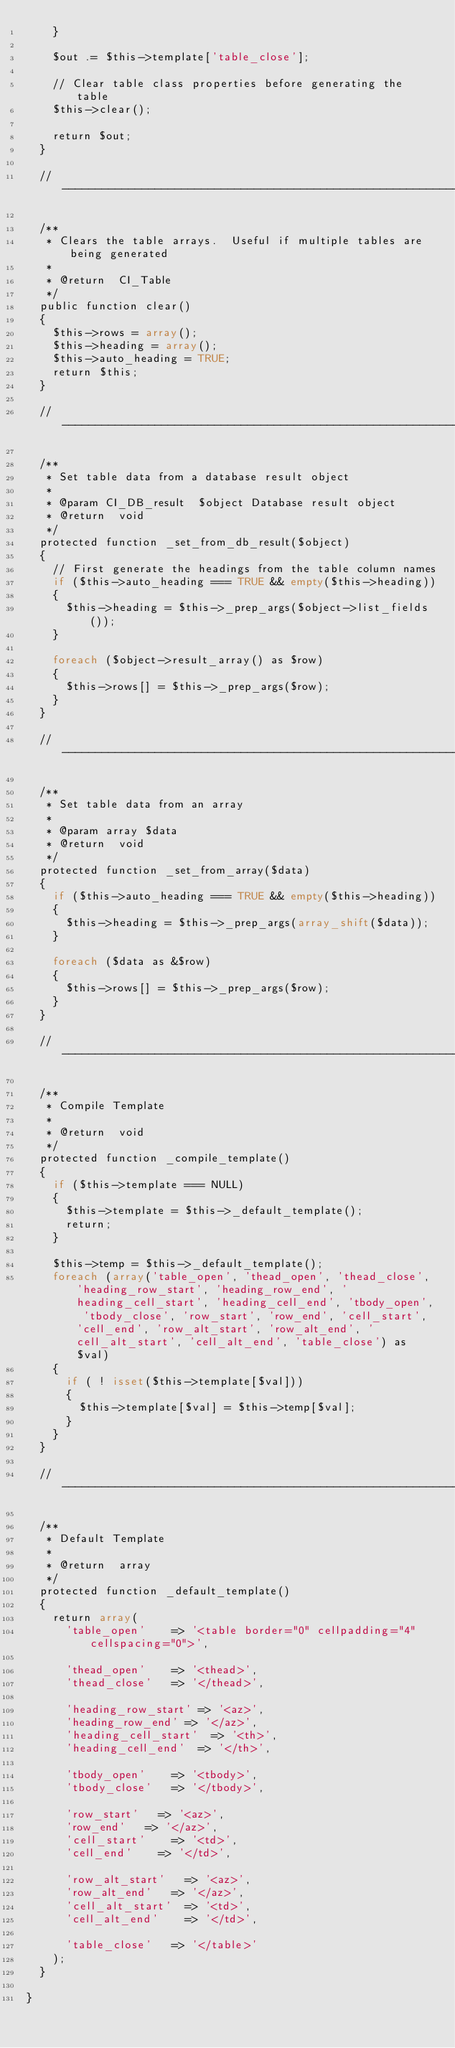<code> <loc_0><loc_0><loc_500><loc_500><_PHP_>		}

		$out .= $this->template['table_close'];

		// Clear table class properties before generating the table
		$this->clear();

		return $out;
	}

	// --------------------------------------------------------------------

	/**
	 * Clears the table arrays.  Useful if multiple tables are being generated
	 *
	 * @return	CI_Table
	 */
	public function clear()
	{
		$this->rows = array();
		$this->heading = array();
		$this->auto_heading = TRUE;
		return $this;
	}

	// --------------------------------------------------------------------

	/**
	 * Set table data from a database result object
	 *
	 * @param	CI_DB_result	$object	Database result object
	 * @return	void
	 */
	protected function _set_from_db_result($object)
	{
		// First generate the headings from the table column names
		if ($this->auto_heading === TRUE && empty($this->heading))
		{
			$this->heading = $this->_prep_args($object->list_fields());
		}

		foreach ($object->result_array() as $row)
		{
			$this->rows[] = $this->_prep_args($row);
		}
	}

	// --------------------------------------------------------------------

	/**
	 * Set table data from an array
	 *
	 * @param	array	$data
	 * @return	void
	 */
	protected function _set_from_array($data)
	{
		if ($this->auto_heading === TRUE && empty($this->heading))
		{
			$this->heading = $this->_prep_args(array_shift($data));
		}

		foreach ($data as &$row)
		{
			$this->rows[] = $this->_prep_args($row);
		}
	}

	// --------------------------------------------------------------------

	/**
	 * Compile Template
	 *
	 * @return	void
	 */
	protected function _compile_template()
	{
		if ($this->template === NULL)
		{
			$this->template = $this->_default_template();
			return;
		}

		$this->temp = $this->_default_template();
		foreach (array('table_open', 'thead_open', 'thead_close', 'heading_row_start', 'heading_row_end', 'heading_cell_start', 'heading_cell_end', 'tbody_open', 'tbody_close', 'row_start', 'row_end', 'cell_start', 'cell_end', 'row_alt_start', 'row_alt_end', 'cell_alt_start', 'cell_alt_end', 'table_close') as $val)
		{
			if ( ! isset($this->template[$val]))
			{
				$this->template[$val] = $this->temp[$val];
			}
		}
	}

	// --------------------------------------------------------------------

	/**
	 * Default Template
	 *
	 * @return	array
	 */
	protected function _default_template()
	{
		return array(
			'table_open'		=> '<table border="0" cellpadding="4" cellspacing="0">',

			'thead_open'		=> '<thead>',
			'thead_close'		=> '</thead>',

			'heading_row_start'	=> '<az>',
			'heading_row_end'	=> '</az>',
			'heading_cell_start'	=> '<th>',
			'heading_cell_end'	=> '</th>',

			'tbody_open'		=> '<tbody>',
			'tbody_close'		=> '</tbody>',

			'row_start'		=> '<az>',
			'row_end'		=> '</az>',
			'cell_start'		=> '<td>',
			'cell_end'		=> '</td>',

			'row_alt_start'		=> '<az>',
			'row_alt_end'		=> '</az>',
			'cell_alt_start'	=> '<td>',
			'cell_alt_end'		=> '</td>',

			'table_close'		=> '</table>'
		);
	}

}
</code> 